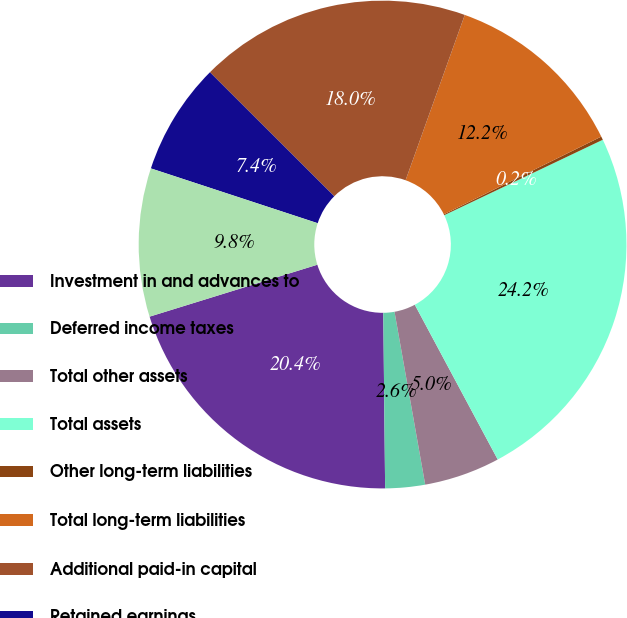Convert chart to OTSL. <chart><loc_0><loc_0><loc_500><loc_500><pie_chart><fcel>Investment in and advances to<fcel>Deferred income taxes<fcel>Total other assets<fcel>Total assets<fcel>Other long-term liabilities<fcel>Total long-term liabilities<fcel>Additional paid-in capital<fcel>Retained earnings<fcel>Accumulated other<nl><fcel>20.39%<fcel>2.63%<fcel>5.03%<fcel>24.24%<fcel>0.23%<fcel>12.23%<fcel>17.99%<fcel>7.43%<fcel>9.83%<nl></chart> 